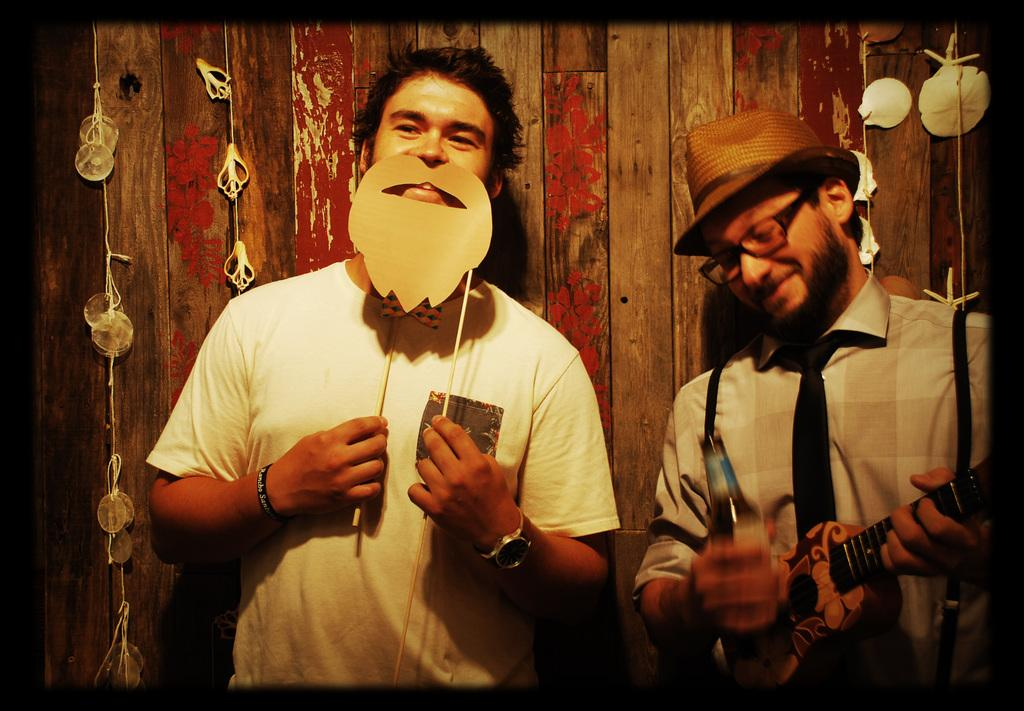Who is present in the image? There are people in the image. What are the people doing in the image? The people are standing. What objects are the people holding in the image? The people are holding a wine bottle and a guitar. How many cobwebs can be seen in the image? There are no cobwebs present in the image. What type of debt is the person in the image trying to pay off? There is no indication of debt in the image; it features people holding a wine bottle and a guitar. 